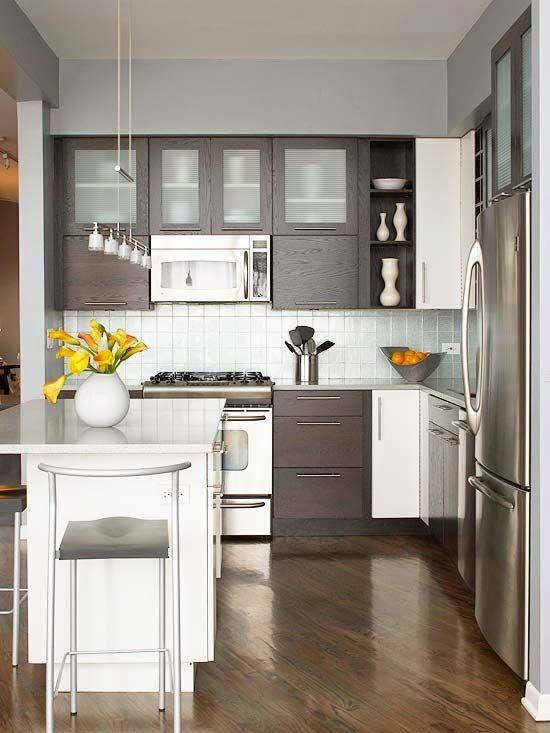What does the choice of flowers and their placement say about the resident's personality? The selection and placement of bright yellow flowers in a white vase in the center of the kitchen suggest that the resident values touches of vibrant, natural beauty to brighten the space. This choice indicates an appreciation for elements that add life and color to a predominantly neutral setting, hinting at a personality that enjoys freshness and vibrancy in their living space, perhaps reflecting a positive, welcoming nature. 